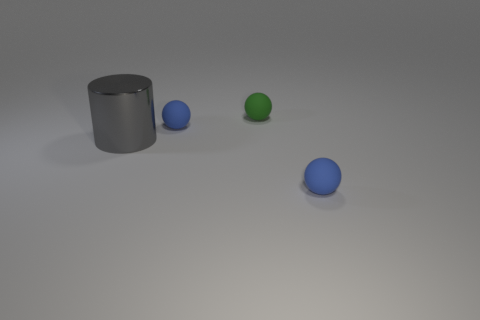Do the large thing and the small green rubber object have the same shape?
Make the answer very short. No. How many big gray shiny things are the same shape as the green matte thing?
Provide a short and direct response. 0. How many balls are behind the large metallic cylinder?
Your answer should be compact. 2. Is the color of the tiny matte thing in front of the gray object the same as the large cylinder?
Provide a short and direct response. No. How many gray things have the same size as the gray shiny cylinder?
Keep it short and to the point. 0. Is there a small matte object of the same color as the metallic cylinder?
Offer a terse response. No. What is the big cylinder made of?
Your answer should be compact. Metal. How many objects are either gray shiny objects or green matte objects?
Provide a short and direct response. 2. What size is the ball that is in front of the large gray metallic thing?
Keep it short and to the point. Small. How many other things are the same material as the green object?
Make the answer very short. 2. 